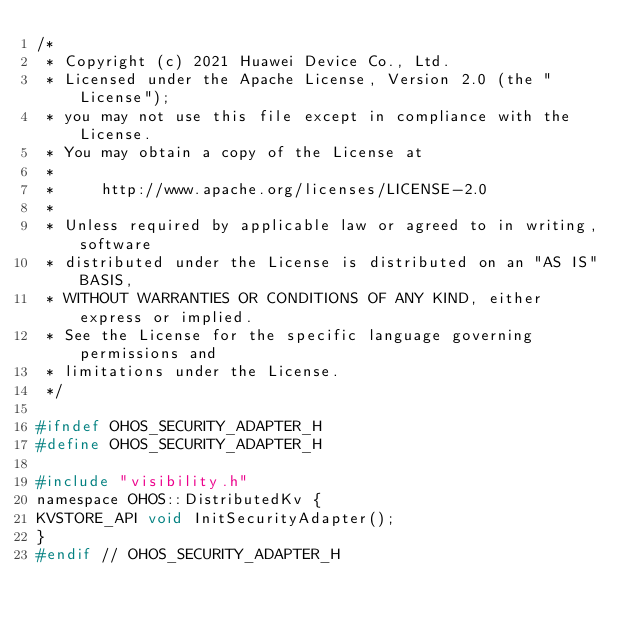<code> <loc_0><loc_0><loc_500><loc_500><_C_>/*
 * Copyright (c) 2021 Huawei Device Co., Ltd.
 * Licensed under the Apache License, Version 2.0 (the "License");
 * you may not use this file except in compliance with the License.
 * You may obtain a copy of the License at
 *
 *     http://www.apache.org/licenses/LICENSE-2.0
 *
 * Unless required by applicable law or agreed to in writing, software
 * distributed under the License is distributed on an "AS IS" BASIS,
 * WITHOUT WARRANTIES OR CONDITIONS OF ANY KIND, either express or implied.
 * See the License for the specific language governing permissions and
 * limitations under the License.
 */

#ifndef OHOS_SECURITY_ADAPTER_H
#define OHOS_SECURITY_ADAPTER_H

#include "visibility.h"
namespace OHOS::DistributedKv {
KVSTORE_API void InitSecurityAdapter();
}
#endif // OHOS_SECURITY_ADAPTER_H
</code> 